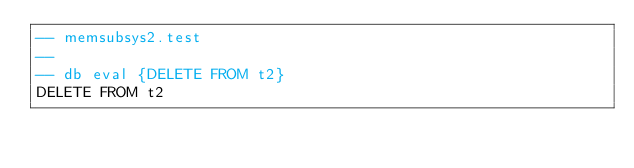Convert code to text. <code><loc_0><loc_0><loc_500><loc_500><_SQL_>-- memsubsys2.test
-- 
-- db eval {DELETE FROM t2}
DELETE FROM t2</code> 